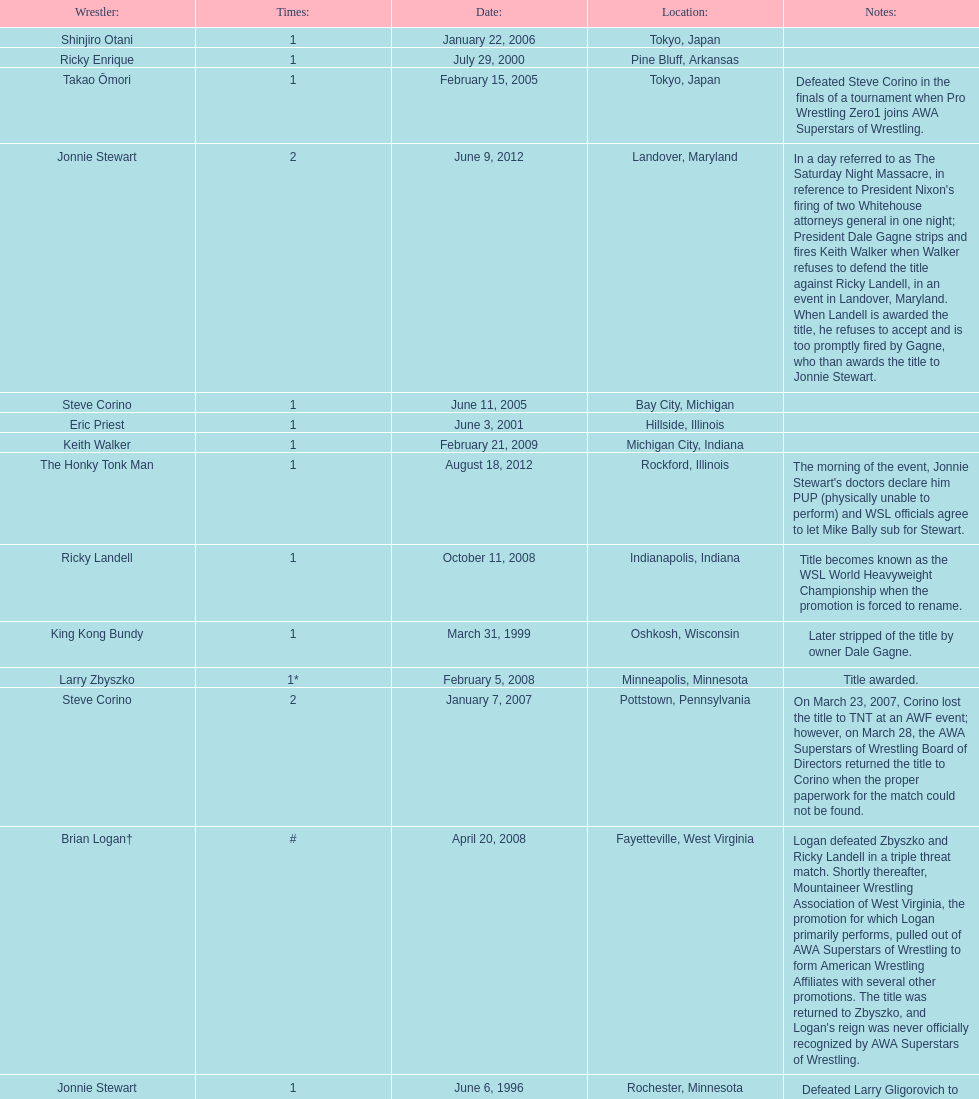Who is the only wsl title holder from texas? Horshu. Give me the full table as a dictionary. {'header': ['Wrestler:', 'Times:', 'Date:', 'Location:', 'Notes:'], 'rows': [['Shinjiro Otani', '1', 'January 22, 2006', 'Tokyo, Japan', ''], ['Ricky Enrique', '1', 'July 29, 2000', 'Pine Bluff, Arkansas', ''], ['Takao Ōmori', '1', 'February 15, 2005', 'Tokyo, Japan', 'Defeated Steve Corino in the finals of a tournament when Pro Wrestling Zero1 joins AWA Superstars of Wrestling.'], ['Jonnie Stewart', '2', 'June 9, 2012', 'Landover, Maryland', "In a day referred to as The Saturday Night Massacre, in reference to President Nixon's firing of two Whitehouse attorneys general in one night; President Dale Gagne strips and fires Keith Walker when Walker refuses to defend the title against Ricky Landell, in an event in Landover, Maryland. When Landell is awarded the title, he refuses to accept and is too promptly fired by Gagne, who than awards the title to Jonnie Stewart."], ['Steve Corino', '1', 'June 11, 2005', 'Bay City, Michigan', ''], ['Eric Priest', '1', 'June 3, 2001', 'Hillside, Illinois', ''], ['Keith Walker', '1', 'February 21, 2009', 'Michigan City, Indiana', ''], ['The Honky Tonk Man', '1', 'August 18, 2012', 'Rockford, Illinois', "The morning of the event, Jonnie Stewart's doctors declare him PUP (physically unable to perform) and WSL officials agree to let Mike Bally sub for Stewart."], ['Ricky Landell', '1', 'October 11, 2008', 'Indianapolis, Indiana', 'Title becomes known as the WSL World Heavyweight Championship when the promotion is forced to rename.'], ['King Kong Bundy', '1', 'March 31, 1999', 'Oshkosh, Wisconsin', 'Later stripped of the title by owner Dale Gagne.'], ['Larry Zbyszko', '1*', 'February 5, 2008', 'Minneapolis, Minnesota', 'Title awarded.'], ['Steve Corino', '2', 'January 7, 2007', 'Pottstown, Pennsylvania', 'On March 23, 2007, Corino lost the title to TNT at an AWF event; however, on March 28, the AWA Superstars of Wrestling Board of Directors returned the title to Corino when the proper paperwork for the match could not be found.'], ['Brian Logan†', '#', 'April 20, 2008', 'Fayetteville, West Virginia', "Logan defeated Zbyszko and Ricky Landell in a triple threat match. Shortly thereafter, Mountaineer Wrestling Association of West Virginia, the promotion for which Logan primarily performs, pulled out of AWA Superstars of Wrestling to form American Wrestling Affiliates with several other promotions. The title was returned to Zbyszko, and Logan's reign was never officially recognized by AWA Superstars of Wrestling."], ['Jonnie Stewart', '1', 'June 6, 1996', 'Rochester, Minnesota', 'Defeated Larry Gligorovich to win the AWA Superstars of Wrestling World Heavyweight Championship.'], ['The Patriot\\n(Danny Dominion)', '1', 'July 29, 2000', 'Pine Bluff, Arkansas', 'Defeated Dale Gagne in an impromptu match to win the title.'], ['Masato Tanaka', '1', 'October 26, 2007', 'Tokyo, Japan', ''], ['Evan Karagias', '1', 'March 22, 2002', 'Casa Grande, Arizona', ''], ['Takao Ōmori', '2', 'April 1, 2006', 'Tokyo, Japan', ''], ['Larry Zbyszko', '1*', '', '', 'Title returned to Zbyszko.'], ['Ric Converse', '1', 'June 14, 2006', 'Indianapolis, Indiana', ''], ['Horshu', '1', 'October 12, 2002', 'Mercedes, Texas', 'Stripped of the title due to missing mandatory title defenses.'], ['Takao Ōmori', '3', 'March 31, 2007', 'Yokohama, Japan', ''], ['Evan Karagias', '2', 'July 6, 2003', 'Lemoore, California', 'Defeated Eric Priest to win the vacated title. Karagias was fired in January 2005 by Dale Gagne for misconduct and refusal of defending the title as scheduled.']]} 